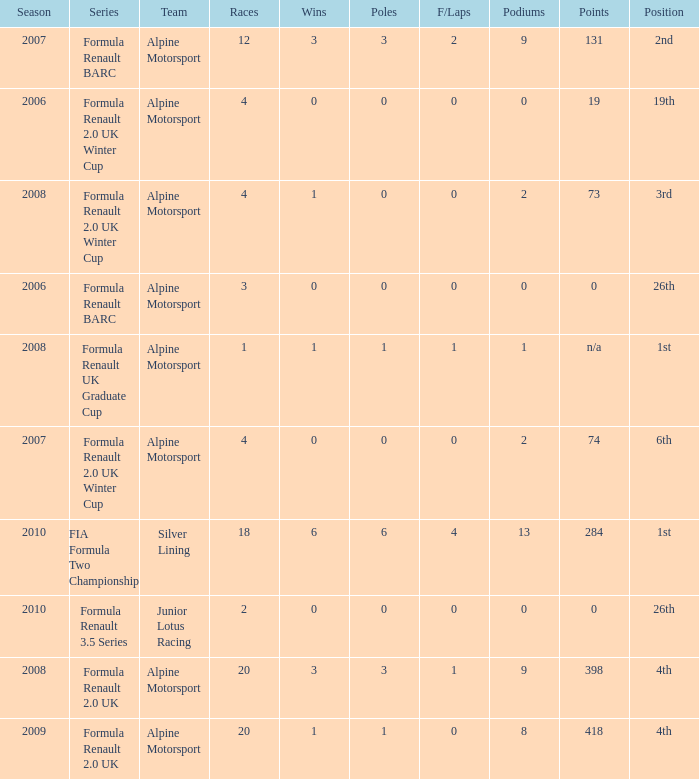What races achieved 0 f/laps and 1 pole position? 20.0. 